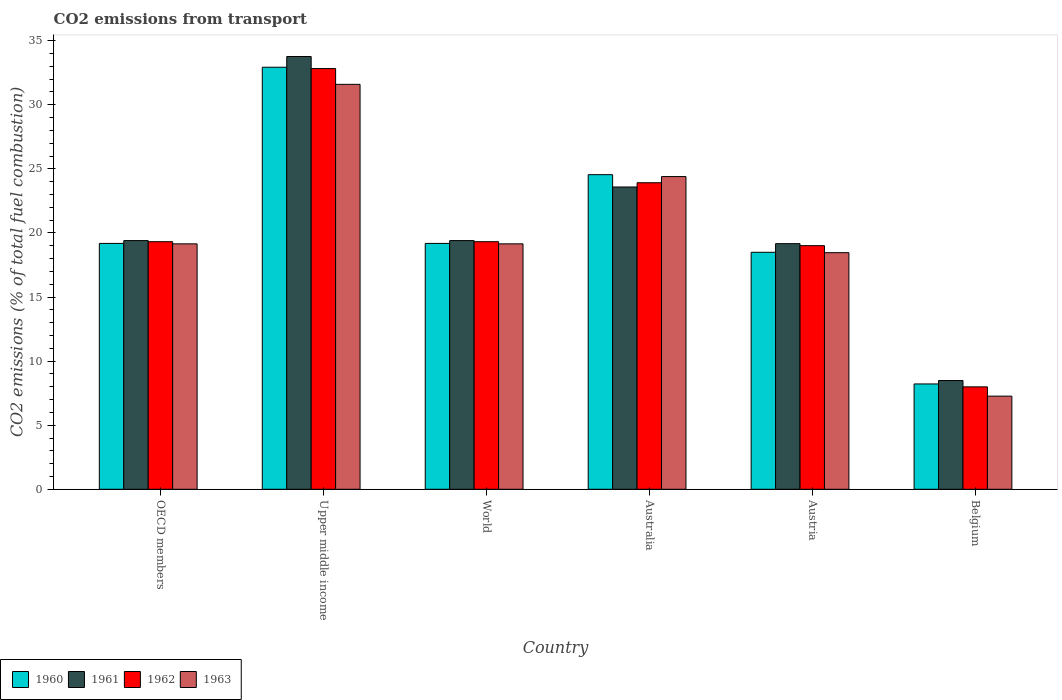Are the number of bars per tick equal to the number of legend labels?
Keep it short and to the point. Yes. What is the label of the 6th group of bars from the left?
Provide a succinct answer. Belgium. What is the total CO2 emitted in 1963 in Belgium?
Offer a terse response. 7.27. Across all countries, what is the maximum total CO2 emitted in 1963?
Provide a succinct answer. 31.59. Across all countries, what is the minimum total CO2 emitted in 1961?
Make the answer very short. 8.49. In which country was the total CO2 emitted in 1963 maximum?
Ensure brevity in your answer.  Upper middle income. What is the total total CO2 emitted in 1963 in the graph?
Provide a succinct answer. 120.01. What is the difference between the total CO2 emitted in 1963 in Belgium and that in World?
Make the answer very short. -11.88. What is the difference between the total CO2 emitted in 1960 in Australia and the total CO2 emitted in 1962 in World?
Provide a succinct answer. 5.23. What is the average total CO2 emitted in 1961 per country?
Provide a short and direct response. 20.63. What is the difference between the total CO2 emitted of/in 1961 and total CO2 emitted of/in 1962 in World?
Give a very brief answer. 0.09. What is the ratio of the total CO2 emitted in 1963 in OECD members to that in Upper middle income?
Offer a terse response. 0.61. Is the total CO2 emitted in 1962 in Australia less than that in OECD members?
Your response must be concise. No. Is the difference between the total CO2 emitted in 1961 in Australia and Upper middle income greater than the difference between the total CO2 emitted in 1962 in Australia and Upper middle income?
Keep it short and to the point. No. What is the difference between the highest and the second highest total CO2 emitted in 1963?
Your response must be concise. 5.25. What is the difference between the highest and the lowest total CO2 emitted in 1960?
Offer a very short reply. 24.71. In how many countries, is the total CO2 emitted in 1963 greater than the average total CO2 emitted in 1963 taken over all countries?
Provide a short and direct response. 2. What does the 3rd bar from the left in Australia represents?
Offer a very short reply. 1962. How many countries are there in the graph?
Provide a succinct answer. 6. What is the difference between two consecutive major ticks on the Y-axis?
Offer a very short reply. 5. Are the values on the major ticks of Y-axis written in scientific E-notation?
Offer a very short reply. No. Does the graph contain grids?
Keep it short and to the point. No. Where does the legend appear in the graph?
Your answer should be very brief. Bottom left. What is the title of the graph?
Offer a very short reply. CO2 emissions from transport. Does "1994" appear as one of the legend labels in the graph?
Ensure brevity in your answer.  No. What is the label or title of the X-axis?
Provide a short and direct response. Country. What is the label or title of the Y-axis?
Give a very brief answer. CO2 emissions (% of total fuel combustion). What is the CO2 emissions (% of total fuel combustion) of 1960 in OECD members?
Make the answer very short. 19.18. What is the CO2 emissions (% of total fuel combustion) in 1961 in OECD members?
Keep it short and to the point. 19.4. What is the CO2 emissions (% of total fuel combustion) of 1962 in OECD members?
Provide a short and direct response. 19.32. What is the CO2 emissions (% of total fuel combustion) of 1963 in OECD members?
Your answer should be compact. 19.15. What is the CO2 emissions (% of total fuel combustion) in 1960 in Upper middle income?
Ensure brevity in your answer.  32.93. What is the CO2 emissions (% of total fuel combustion) in 1961 in Upper middle income?
Provide a succinct answer. 33.76. What is the CO2 emissions (% of total fuel combustion) of 1962 in Upper middle income?
Your response must be concise. 32.82. What is the CO2 emissions (% of total fuel combustion) in 1963 in Upper middle income?
Make the answer very short. 31.59. What is the CO2 emissions (% of total fuel combustion) in 1960 in World?
Provide a short and direct response. 19.18. What is the CO2 emissions (% of total fuel combustion) in 1961 in World?
Provide a succinct answer. 19.4. What is the CO2 emissions (% of total fuel combustion) in 1962 in World?
Your answer should be very brief. 19.32. What is the CO2 emissions (% of total fuel combustion) in 1963 in World?
Offer a terse response. 19.15. What is the CO2 emissions (% of total fuel combustion) in 1960 in Australia?
Give a very brief answer. 24.55. What is the CO2 emissions (% of total fuel combustion) in 1961 in Australia?
Your response must be concise. 23.59. What is the CO2 emissions (% of total fuel combustion) of 1962 in Australia?
Ensure brevity in your answer.  23.92. What is the CO2 emissions (% of total fuel combustion) in 1963 in Australia?
Offer a terse response. 24.4. What is the CO2 emissions (% of total fuel combustion) of 1960 in Austria?
Give a very brief answer. 18.49. What is the CO2 emissions (% of total fuel combustion) of 1961 in Austria?
Keep it short and to the point. 19.16. What is the CO2 emissions (% of total fuel combustion) of 1962 in Austria?
Give a very brief answer. 19.01. What is the CO2 emissions (% of total fuel combustion) of 1963 in Austria?
Ensure brevity in your answer.  18.46. What is the CO2 emissions (% of total fuel combustion) in 1960 in Belgium?
Offer a terse response. 8.22. What is the CO2 emissions (% of total fuel combustion) of 1961 in Belgium?
Ensure brevity in your answer.  8.49. What is the CO2 emissions (% of total fuel combustion) in 1962 in Belgium?
Offer a terse response. 7.99. What is the CO2 emissions (% of total fuel combustion) in 1963 in Belgium?
Offer a terse response. 7.27. Across all countries, what is the maximum CO2 emissions (% of total fuel combustion) of 1960?
Provide a short and direct response. 32.93. Across all countries, what is the maximum CO2 emissions (% of total fuel combustion) of 1961?
Provide a short and direct response. 33.76. Across all countries, what is the maximum CO2 emissions (% of total fuel combustion) in 1962?
Your answer should be very brief. 32.82. Across all countries, what is the maximum CO2 emissions (% of total fuel combustion) in 1963?
Your answer should be very brief. 31.59. Across all countries, what is the minimum CO2 emissions (% of total fuel combustion) of 1960?
Offer a terse response. 8.22. Across all countries, what is the minimum CO2 emissions (% of total fuel combustion) in 1961?
Provide a succinct answer. 8.49. Across all countries, what is the minimum CO2 emissions (% of total fuel combustion) of 1962?
Provide a succinct answer. 7.99. Across all countries, what is the minimum CO2 emissions (% of total fuel combustion) in 1963?
Your answer should be compact. 7.27. What is the total CO2 emissions (% of total fuel combustion) of 1960 in the graph?
Give a very brief answer. 122.55. What is the total CO2 emissions (% of total fuel combustion) of 1961 in the graph?
Make the answer very short. 123.8. What is the total CO2 emissions (% of total fuel combustion) of 1962 in the graph?
Keep it short and to the point. 122.37. What is the total CO2 emissions (% of total fuel combustion) in 1963 in the graph?
Give a very brief answer. 120.01. What is the difference between the CO2 emissions (% of total fuel combustion) in 1960 in OECD members and that in Upper middle income?
Provide a short and direct response. -13.75. What is the difference between the CO2 emissions (% of total fuel combustion) of 1961 in OECD members and that in Upper middle income?
Your answer should be very brief. -14.36. What is the difference between the CO2 emissions (% of total fuel combustion) of 1962 in OECD members and that in Upper middle income?
Your response must be concise. -13.51. What is the difference between the CO2 emissions (% of total fuel combustion) in 1963 in OECD members and that in Upper middle income?
Your response must be concise. -12.44. What is the difference between the CO2 emissions (% of total fuel combustion) of 1961 in OECD members and that in World?
Offer a terse response. 0. What is the difference between the CO2 emissions (% of total fuel combustion) in 1960 in OECD members and that in Australia?
Ensure brevity in your answer.  -5.36. What is the difference between the CO2 emissions (% of total fuel combustion) in 1961 in OECD members and that in Australia?
Provide a short and direct response. -4.18. What is the difference between the CO2 emissions (% of total fuel combustion) in 1962 in OECD members and that in Australia?
Make the answer very short. -4.6. What is the difference between the CO2 emissions (% of total fuel combustion) of 1963 in OECD members and that in Australia?
Give a very brief answer. -5.25. What is the difference between the CO2 emissions (% of total fuel combustion) in 1960 in OECD members and that in Austria?
Ensure brevity in your answer.  0.69. What is the difference between the CO2 emissions (% of total fuel combustion) of 1961 in OECD members and that in Austria?
Give a very brief answer. 0.24. What is the difference between the CO2 emissions (% of total fuel combustion) in 1962 in OECD members and that in Austria?
Your answer should be compact. 0.31. What is the difference between the CO2 emissions (% of total fuel combustion) of 1963 in OECD members and that in Austria?
Offer a terse response. 0.69. What is the difference between the CO2 emissions (% of total fuel combustion) of 1960 in OECD members and that in Belgium?
Give a very brief answer. 10.96. What is the difference between the CO2 emissions (% of total fuel combustion) of 1961 in OECD members and that in Belgium?
Keep it short and to the point. 10.92. What is the difference between the CO2 emissions (% of total fuel combustion) in 1962 in OECD members and that in Belgium?
Offer a very short reply. 11.33. What is the difference between the CO2 emissions (% of total fuel combustion) of 1963 in OECD members and that in Belgium?
Your response must be concise. 11.88. What is the difference between the CO2 emissions (% of total fuel combustion) of 1960 in Upper middle income and that in World?
Your answer should be very brief. 13.75. What is the difference between the CO2 emissions (% of total fuel combustion) in 1961 in Upper middle income and that in World?
Make the answer very short. 14.36. What is the difference between the CO2 emissions (% of total fuel combustion) in 1962 in Upper middle income and that in World?
Offer a terse response. 13.51. What is the difference between the CO2 emissions (% of total fuel combustion) of 1963 in Upper middle income and that in World?
Ensure brevity in your answer.  12.44. What is the difference between the CO2 emissions (% of total fuel combustion) in 1960 in Upper middle income and that in Australia?
Your answer should be compact. 8.38. What is the difference between the CO2 emissions (% of total fuel combustion) in 1961 in Upper middle income and that in Australia?
Make the answer very short. 10.18. What is the difference between the CO2 emissions (% of total fuel combustion) in 1962 in Upper middle income and that in Australia?
Make the answer very short. 8.91. What is the difference between the CO2 emissions (% of total fuel combustion) of 1963 in Upper middle income and that in Australia?
Give a very brief answer. 7.2. What is the difference between the CO2 emissions (% of total fuel combustion) of 1960 in Upper middle income and that in Austria?
Ensure brevity in your answer.  14.44. What is the difference between the CO2 emissions (% of total fuel combustion) of 1961 in Upper middle income and that in Austria?
Keep it short and to the point. 14.6. What is the difference between the CO2 emissions (% of total fuel combustion) of 1962 in Upper middle income and that in Austria?
Keep it short and to the point. 13.82. What is the difference between the CO2 emissions (% of total fuel combustion) in 1963 in Upper middle income and that in Austria?
Provide a short and direct response. 13.13. What is the difference between the CO2 emissions (% of total fuel combustion) of 1960 in Upper middle income and that in Belgium?
Make the answer very short. 24.71. What is the difference between the CO2 emissions (% of total fuel combustion) in 1961 in Upper middle income and that in Belgium?
Make the answer very short. 25.28. What is the difference between the CO2 emissions (% of total fuel combustion) of 1962 in Upper middle income and that in Belgium?
Your response must be concise. 24.83. What is the difference between the CO2 emissions (% of total fuel combustion) of 1963 in Upper middle income and that in Belgium?
Your answer should be compact. 24.33. What is the difference between the CO2 emissions (% of total fuel combustion) in 1960 in World and that in Australia?
Offer a terse response. -5.36. What is the difference between the CO2 emissions (% of total fuel combustion) in 1961 in World and that in Australia?
Your response must be concise. -4.18. What is the difference between the CO2 emissions (% of total fuel combustion) in 1962 in World and that in Australia?
Keep it short and to the point. -4.6. What is the difference between the CO2 emissions (% of total fuel combustion) in 1963 in World and that in Australia?
Offer a very short reply. -5.25. What is the difference between the CO2 emissions (% of total fuel combustion) in 1960 in World and that in Austria?
Ensure brevity in your answer.  0.69. What is the difference between the CO2 emissions (% of total fuel combustion) of 1961 in World and that in Austria?
Offer a terse response. 0.24. What is the difference between the CO2 emissions (% of total fuel combustion) of 1962 in World and that in Austria?
Offer a very short reply. 0.31. What is the difference between the CO2 emissions (% of total fuel combustion) of 1963 in World and that in Austria?
Your response must be concise. 0.69. What is the difference between the CO2 emissions (% of total fuel combustion) in 1960 in World and that in Belgium?
Keep it short and to the point. 10.96. What is the difference between the CO2 emissions (% of total fuel combustion) of 1961 in World and that in Belgium?
Offer a terse response. 10.92. What is the difference between the CO2 emissions (% of total fuel combustion) in 1962 in World and that in Belgium?
Your answer should be very brief. 11.33. What is the difference between the CO2 emissions (% of total fuel combustion) of 1963 in World and that in Belgium?
Your answer should be very brief. 11.88. What is the difference between the CO2 emissions (% of total fuel combustion) in 1960 in Australia and that in Austria?
Your response must be concise. 6.06. What is the difference between the CO2 emissions (% of total fuel combustion) in 1961 in Australia and that in Austria?
Make the answer very short. 4.42. What is the difference between the CO2 emissions (% of total fuel combustion) of 1962 in Australia and that in Austria?
Your answer should be compact. 4.91. What is the difference between the CO2 emissions (% of total fuel combustion) of 1963 in Australia and that in Austria?
Give a very brief answer. 5.94. What is the difference between the CO2 emissions (% of total fuel combustion) in 1960 in Australia and that in Belgium?
Your answer should be compact. 16.33. What is the difference between the CO2 emissions (% of total fuel combustion) in 1961 in Australia and that in Belgium?
Provide a succinct answer. 15.1. What is the difference between the CO2 emissions (% of total fuel combustion) of 1962 in Australia and that in Belgium?
Offer a very short reply. 15.93. What is the difference between the CO2 emissions (% of total fuel combustion) of 1963 in Australia and that in Belgium?
Give a very brief answer. 17.13. What is the difference between the CO2 emissions (% of total fuel combustion) in 1960 in Austria and that in Belgium?
Make the answer very short. 10.27. What is the difference between the CO2 emissions (% of total fuel combustion) of 1961 in Austria and that in Belgium?
Give a very brief answer. 10.68. What is the difference between the CO2 emissions (% of total fuel combustion) in 1962 in Austria and that in Belgium?
Make the answer very short. 11.02. What is the difference between the CO2 emissions (% of total fuel combustion) in 1963 in Austria and that in Belgium?
Give a very brief answer. 11.19. What is the difference between the CO2 emissions (% of total fuel combustion) in 1960 in OECD members and the CO2 emissions (% of total fuel combustion) in 1961 in Upper middle income?
Your response must be concise. -14.58. What is the difference between the CO2 emissions (% of total fuel combustion) of 1960 in OECD members and the CO2 emissions (% of total fuel combustion) of 1962 in Upper middle income?
Give a very brief answer. -13.64. What is the difference between the CO2 emissions (% of total fuel combustion) in 1960 in OECD members and the CO2 emissions (% of total fuel combustion) in 1963 in Upper middle income?
Make the answer very short. -12.41. What is the difference between the CO2 emissions (% of total fuel combustion) of 1961 in OECD members and the CO2 emissions (% of total fuel combustion) of 1962 in Upper middle income?
Your answer should be compact. -13.42. What is the difference between the CO2 emissions (% of total fuel combustion) in 1961 in OECD members and the CO2 emissions (% of total fuel combustion) in 1963 in Upper middle income?
Keep it short and to the point. -12.19. What is the difference between the CO2 emissions (% of total fuel combustion) in 1962 in OECD members and the CO2 emissions (% of total fuel combustion) in 1963 in Upper middle income?
Make the answer very short. -12.28. What is the difference between the CO2 emissions (% of total fuel combustion) in 1960 in OECD members and the CO2 emissions (% of total fuel combustion) in 1961 in World?
Ensure brevity in your answer.  -0.22. What is the difference between the CO2 emissions (% of total fuel combustion) of 1960 in OECD members and the CO2 emissions (% of total fuel combustion) of 1962 in World?
Provide a short and direct response. -0.13. What is the difference between the CO2 emissions (% of total fuel combustion) in 1960 in OECD members and the CO2 emissions (% of total fuel combustion) in 1963 in World?
Offer a very short reply. 0.03. What is the difference between the CO2 emissions (% of total fuel combustion) of 1961 in OECD members and the CO2 emissions (% of total fuel combustion) of 1962 in World?
Your answer should be very brief. 0.09. What is the difference between the CO2 emissions (% of total fuel combustion) in 1961 in OECD members and the CO2 emissions (% of total fuel combustion) in 1963 in World?
Provide a succinct answer. 0.25. What is the difference between the CO2 emissions (% of total fuel combustion) of 1962 in OECD members and the CO2 emissions (% of total fuel combustion) of 1963 in World?
Offer a terse response. 0.17. What is the difference between the CO2 emissions (% of total fuel combustion) of 1960 in OECD members and the CO2 emissions (% of total fuel combustion) of 1961 in Australia?
Your answer should be very brief. -4.4. What is the difference between the CO2 emissions (% of total fuel combustion) of 1960 in OECD members and the CO2 emissions (% of total fuel combustion) of 1962 in Australia?
Offer a very short reply. -4.73. What is the difference between the CO2 emissions (% of total fuel combustion) in 1960 in OECD members and the CO2 emissions (% of total fuel combustion) in 1963 in Australia?
Ensure brevity in your answer.  -5.21. What is the difference between the CO2 emissions (% of total fuel combustion) of 1961 in OECD members and the CO2 emissions (% of total fuel combustion) of 1962 in Australia?
Make the answer very short. -4.51. What is the difference between the CO2 emissions (% of total fuel combustion) of 1961 in OECD members and the CO2 emissions (% of total fuel combustion) of 1963 in Australia?
Your response must be concise. -4.99. What is the difference between the CO2 emissions (% of total fuel combustion) of 1962 in OECD members and the CO2 emissions (% of total fuel combustion) of 1963 in Australia?
Ensure brevity in your answer.  -5.08. What is the difference between the CO2 emissions (% of total fuel combustion) of 1960 in OECD members and the CO2 emissions (% of total fuel combustion) of 1961 in Austria?
Offer a terse response. 0.02. What is the difference between the CO2 emissions (% of total fuel combustion) of 1960 in OECD members and the CO2 emissions (% of total fuel combustion) of 1962 in Austria?
Provide a short and direct response. 0.18. What is the difference between the CO2 emissions (% of total fuel combustion) of 1960 in OECD members and the CO2 emissions (% of total fuel combustion) of 1963 in Austria?
Ensure brevity in your answer.  0.72. What is the difference between the CO2 emissions (% of total fuel combustion) in 1961 in OECD members and the CO2 emissions (% of total fuel combustion) in 1962 in Austria?
Give a very brief answer. 0.4. What is the difference between the CO2 emissions (% of total fuel combustion) of 1961 in OECD members and the CO2 emissions (% of total fuel combustion) of 1963 in Austria?
Give a very brief answer. 0.94. What is the difference between the CO2 emissions (% of total fuel combustion) in 1962 in OECD members and the CO2 emissions (% of total fuel combustion) in 1963 in Austria?
Give a very brief answer. 0.86. What is the difference between the CO2 emissions (% of total fuel combustion) in 1960 in OECD members and the CO2 emissions (% of total fuel combustion) in 1961 in Belgium?
Your answer should be very brief. 10.7. What is the difference between the CO2 emissions (% of total fuel combustion) of 1960 in OECD members and the CO2 emissions (% of total fuel combustion) of 1962 in Belgium?
Your answer should be compact. 11.19. What is the difference between the CO2 emissions (% of total fuel combustion) of 1960 in OECD members and the CO2 emissions (% of total fuel combustion) of 1963 in Belgium?
Your response must be concise. 11.92. What is the difference between the CO2 emissions (% of total fuel combustion) of 1961 in OECD members and the CO2 emissions (% of total fuel combustion) of 1962 in Belgium?
Ensure brevity in your answer.  11.41. What is the difference between the CO2 emissions (% of total fuel combustion) in 1961 in OECD members and the CO2 emissions (% of total fuel combustion) in 1963 in Belgium?
Offer a very short reply. 12.14. What is the difference between the CO2 emissions (% of total fuel combustion) of 1962 in OECD members and the CO2 emissions (% of total fuel combustion) of 1963 in Belgium?
Make the answer very short. 12.05. What is the difference between the CO2 emissions (% of total fuel combustion) of 1960 in Upper middle income and the CO2 emissions (% of total fuel combustion) of 1961 in World?
Keep it short and to the point. 13.53. What is the difference between the CO2 emissions (% of total fuel combustion) of 1960 in Upper middle income and the CO2 emissions (% of total fuel combustion) of 1962 in World?
Offer a terse response. 13.61. What is the difference between the CO2 emissions (% of total fuel combustion) of 1960 in Upper middle income and the CO2 emissions (% of total fuel combustion) of 1963 in World?
Provide a succinct answer. 13.78. What is the difference between the CO2 emissions (% of total fuel combustion) in 1961 in Upper middle income and the CO2 emissions (% of total fuel combustion) in 1962 in World?
Give a very brief answer. 14.45. What is the difference between the CO2 emissions (% of total fuel combustion) of 1961 in Upper middle income and the CO2 emissions (% of total fuel combustion) of 1963 in World?
Give a very brief answer. 14.62. What is the difference between the CO2 emissions (% of total fuel combustion) of 1962 in Upper middle income and the CO2 emissions (% of total fuel combustion) of 1963 in World?
Make the answer very short. 13.68. What is the difference between the CO2 emissions (% of total fuel combustion) of 1960 in Upper middle income and the CO2 emissions (% of total fuel combustion) of 1961 in Australia?
Keep it short and to the point. 9.34. What is the difference between the CO2 emissions (% of total fuel combustion) of 1960 in Upper middle income and the CO2 emissions (% of total fuel combustion) of 1962 in Australia?
Offer a very short reply. 9.01. What is the difference between the CO2 emissions (% of total fuel combustion) of 1960 in Upper middle income and the CO2 emissions (% of total fuel combustion) of 1963 in Australia?
Your answer should be very brief. 8.53. What is the difference between the CO2 emissions (% of total fuel combustion) of 1961 in Upper middle income and the CO2 emissions (% of total fuel combustion) of 1962 in Australia?
Ensure brevity in your answer.  9.85. What is the difference between the CO2 emissions (% of total fuel combustion) in 1961 in Upper middle income and the CO2 emissions (% of total fuel combustion) in 1963 in Australia?
Offer a terse response. 9.37. What is the difference between the CO2 emissions (% of total fuel combustion) of 1962 in Upper middle income and the CO2 emissions (% of total fuel combustion) of 1963 in Australia?
Your answer should be very brief. 8.43. What is the difference between the CO2 emissions (% of total fuel combustion) of 1960 in Upper middle income and the CO2 emissions (% of total fuel combustion) of 1961 in Austria?
Your answer should be very brief. 13.77. What is the difference between the CO2 emissions (% of total fuel combustion) of 1960 in Upper middle income and the CO2 emissions (% of total fuel combustion) of 1962 in Austria?
Provide a succinct answer. 13.92. What is the difference between the CO2 emissions (% of total fuel combustion) of 1960 in Upper middle income and the CO2 emissions (% of total fuel combustion) of 1963 in Austria?
Ensure brevity in your answer.  14.47. What is the difference between the CO2 emissions (% of total fuel combustion) in 1961 in Upper middle income and the CO2 emissions (% of total fuel combustion) in 1962 in Austria?
Provide a short and direct response. 14.76. What is the difference between the CO2 emissions (% of total fuel combustion) in 1961 in Upper middle income and the CO2 emissions (% of total fuel combustion) in 1963 in Austria?
Provide a short and direct response. 15.3. What is the difference between the CO2 emissions (% of total fuel combustion) of 1962 in Upper middle income and the CO2 emissions (% of total fuel combustion) of 1963 in Austria?
Offer a very short reply. 14.36. What is the difference between the CO2 emissions (% of total fuel combustion) of 1960 in Upper middle income and the CO2 emissions (% of total fuel combustion) of 1961 in Belgium?
Provide a succinct answer. 24.44. What is the difference between the CO2 emissions (% of total fuel combustion) in 1960 in Upper middle income and the CO2 emissions (% of total fuel combustion) in 1962 in Belgium?
Make the answer very short. 24.94. What is the difference between the CO2 emissions (% of total fuel combustion) of 1960 in Upper middle income and the CO2 emissions (% of total fuel combustion) of 1963 in Belgium?
Offer a terse response. 25.66. What is the difference between the CO2 emissions (% of total fuel combustion) in 1961 in Upper middle income and the CO2 emissions (% of total fuel combustion) in 1962 in Belgium?
Keep it short and to the point. 25.77. What is the difference between the CO2 emissions (% of total fuel combustion) in 1961 in Upper middle income and the CO2 emissions (% of total fuel combustion) in 1963 in Belgium?
Keep it short and to the point. 26.5. What is the difference between the CO2 emissions (% of total fuel combustion) of 1962 in Upper middle income and the CO2 emissions (% of total fuel combustion) of 1963 in Belgium?
Ensure brevity in your answer.  25.56. What is the difference between the CO2 emissions (% of total fuel combustion) of 1960 in World and the CO2 emissions (% of total fuel combustion) of 1961 in Australia?
Keep it short and to the point. -4.4. What is the difference between the CO2 emissions (% of total fuel combustion) in 1960 in World and the CO2 emissions (% of total fuel combustion) in 1962 in Australia?
Keep it short and to the point. -4.73. What is the difference between the CO2 emissions (% of total fuel combustion) in 1960 in World and the CO2 emissions (% of total fuel combustion) in 1963 in Australia?
Give a very brief answer. -5.21. What is the difference between the CO2 emissions (% of total fuel combustion) of 1961 in World and the CO2 emissions (% of total fuel combustion) of 1962 in Australia?
Provide a succinct answer. -4.51. What is the difference between the CO2 emissions (% of total fuel combustion) of 1961 in World and the CO2 emissions (% of total fuel combustion) of 1963 in Australia?
Your answer should be compact. -4.99. What is the difference between the CO2 emissions (% of total fuel combustion) of 1962 in World and the CO2 emissions (% of total fuel combustion) of 1963 in Australia?
Provide a succinct answer. -5.08. What is the difference between the CO2 emissions (% of total fuel combustion) of 1960 in World and the CO2 emissions (% of total fuel combustion) of 1961 in Austria?
Offer a terse response. 0.02. What is the difference between the CO2 emissions (% of total fuel combustion) in 1960 in World and the CO2 emissions (% of total fuel combustion) in 1962 in Austria?
Make the answer very short. 0.18. What is the difference between the CO2 emissions (% of total fuel combustion) of 1960 in World and the CO2 emissions (% of total fuel combustion) of 1963 in Austria?
Provide a short and direct response. 0.72. What is the difference between the CO2 emissions (% of total fuel combustion) of 1961 in World and the CO2 emissions (% of total fuel combustion) of 1962 in Austria?
Your answer should be very brief. 0.4. What is the difference between the CO2 emissions (% of total fuel combustion) of 1961 in World and the CO2 emissions (% of total fuel combustion) of 1963 in Austria?
Your response must be concise. 0.94. What is the difference between the CO2 emissions (% of total fuel combustion) in 1962 in World and the CO2 emissions (% of total fuel combustion) in 1963 in Austria?
Ensure brevity in your answer.  0.86. What is the difference between the CO2 emissions (% of total fuel combustion) in 1960 in World and the CO2 emissions (% of total fuel combustion) in 1961 in Belgium?
Keep it short and to the point. 10.7. What is the difference between the CO2 emissions (% of total fuel combustion) of 1960 in World and the CO2 emissions (% of total fuel combustion) of 1962 in Belgium?
Provide a short and direct response. 11.19. What is the difference between the CO2 emissions (% of total fuel combustion) of 1960 in World and the CO2 emissions (% of total fuel combustion) of 1963 in Belgium?
Offer a terse response. 11.92. What is the difference between the CO2 emissions (% of total fuel combustion) of 1961 in World and the CO2 emissions (% of total fuel combustion) of 1962 in Belgium?
Your answer should be compact. 11.41. What is the difference between the CO2 emissions (% of total fuel combustion) in 1961 in World and the CO2 emissions (% of total fuel combustion) in 1963 in Belgium?
Provide a short and direct response. 12.14. What is the difference between the CO2 emissions (% of total fuel combustion) of 1962 in World and the CO2 emissions (% of total fuel combustion) of 1963 in Belgium?
Give a very brief answer. 12.05. What is the difference between the CO2 emissions (% of total fuel combustion) in 1960 in Australia and the CO2 emissions (% of total fuel combustion) in 1961 in Austria?
Your answer should be very brief. 5.38. What is the difference between the CO2 emissions (% of total fuel combustion) in 1960 in Australia and the CO2 emissions (% of total fuel combustion) in 1962 in Austria?
Your answer should be very brief. 5.54. What is the difference between the CO2 emissions (% of total fuel combustion) in 1960 in Australia and the CO2 emissions (% of total fuel combustion) in 1963 in Austria?
Provide a short and direct response. 6.09. What is the difference between the CO2 emissions (% of total fuel combustion) of 1961 in Australia and the CO2 emissions (% of total fuel combustion) of 1962 in Austria?
Offer a very short reply. 4.58. What is the difference between the CO2 emissions (% of total fuel combustion) of 1961 in Australia and the CO2 emissions (% of total fuel combustion) of 1963 in Austria?
Your answer should be very brief. 5.13. What is the difference between the CO2 emissions (% of total fuel combustion) of 1962 in Australia and the CO2 emissions (% of total fuel combustion) of 1963 in Austria?
Keep it short and to the point. 5.46. What is the difference between the CO2 emissions (% of total fuel combustion) in 1960 in Australia and the CO2 emissions (% of total fuel combustion) in 1961 in Belgium?
Offer a terse response. 16.06. What is the difference between the CO2 emissions (% of total fuel combustion) of 1960 in Australia and the CO2 emissions (% of total fuel combustion) of 1962 in Belgium?
Keep it short and to the point. 16.56. What is the difference between the CO2 emissions (% of total fuel combustion) of 1960 in Australia and the CO2 emissions (% of total fuel combustion) of 1963 in Belgium?
Your answer should be very brief. 17.28. What is the difference between the CO2 emissions (% of total fuel combustion) in 1961 in Australia and the CO2 emissions (% of total fuel combustion) in 1962 in Belgium?
Offer a very short reply. 15.59. What is the difference between the CO2 emissions (% of total fuel combustion) in 1961 in Australia and the CO2 emissions (% of total fuel combustion) in 1963 in Belgium?
Your answer should be very brief. 16.32. What is the difference between the CO2 emissions (% of total fuel combustion) in 1962 in Australia and the CO2 emissions (% of total fuel combustion) in 1963 in Belgium?
Provide a short and direct response. 16.65. What is the difference between the CO2 emissions (% of total fuel combustion) in 1960 in Austria and the CO2 emissions (% of total fuel combustion) in 1961 in Belgium?
Make the answer very short. 10. What is the difference between the CO2 emissions (% of total fuel combustion) of 1960 in Austria and the CO2 emissions (% of total fuel combustion) of 1962 in Belgium?
Offer a very short reply. 10.5. What is the difference between the CO2 emissions (% of total fuel combustion) in 1960 in Austria and the CO2 emissions (% of total fuel combustion) in 1963 in Belgium?
Provide a short and direct response. 11.22. What is the difference between the CO2 emissions (% of total fuel combustion) of 1961 in Austria and the CO2 emissions (% of total fuel combustion) of 1962 in Belgium?
Make the answer very short. 11.17. What is the difference between the CO2 emissions (% of total fuel combustion) in 1961 in Austria and the CO2 emissions (% of total fuel combustion) in 1963 in Belgium?
Make the answer very short. 11.9. What is the difference between the CO2 emissions (% of total fuel combustion) of 1962 in Austria and the CO2 emissions (% of total fuel combustion) of 1963 in Belgium?
Your response must be concise. 11.74. What is the average CO2 emissions (% of total fuel combustion) in 1960 per country?
Provide a succinct answer. 20.42. What is the average CO2 emissions (% of total fuel combustion) in 1961 per country?
Provide a short and direct response. 20.63. What is the average CO2 emissions (% of total fuel combustion) in 1962 per country?
Keep it short and to the point. 20.4. What is the average CO2 emissions (% of total fuel combustion) in 1963 per country?
Your response must be concise. 20. What is the difference between the CO2 emissions (% of total fuel combustion) in 1960 and CO2 emissions (% of total fuel combustion) in 1961 in OECD members?
Provide a succinct answer. -0.22. What is the difference between the CO2 emissions (% of total fuel combustion) in 1960 and CO2 emissions (% of total fuel combustion) in 1962 in OECD members?
Provide a succinct answer. -0.13. What is the difference between the CO2 emissions (% of total fuel combustion) in 1960 and CO2 emissions (% of total fuel combustion) in 1963 in OECD members?
Provide a succinct answer. 0.03. What is the difference between the CO2 emissions (% of total fuel combustion) in 1961 and CO2 emissions (% of total fuel combustion) in 1962 in OECD members?
Your answer should be very brief. 0.09. What is the difference between the CO2 emissions (% of total fuel combustion) of 1961 and CO2 emissions (% of total fuel combustion) of 1963 in OECD members?
Offer a very short reply. 0.25. What is the difference between the CO2 emissions (% of total fuel combustion) in 1962 and CO2 emissions (% of total fuel combustion) in 1963 in OECD members?
Offer a very short reply. 0.17. What is the difference between the CO2 emissions (% of total fuel combustion) of 1960 and CO2 emissions (% of total fuel combustion) of 1961 in Upper middle income?
Offer a very short reply. -0.84. What is the difference between the CO2 emissions (% of total fuel combustion) of 1960 and CO2 emissions (% of total fuel combustion) of 1962 in Upper middle income?
Ensure brevity in your answer.  0.1. What is the difference between the CO2 emissions (% of total fuel combustion) of 1960 and CO2 emissions (% of total fuel combustion) of 1963 in Upper middle income?
Provide a succinct answer. 1.34. What is the difference between the CO2 emissions (% of total fuel combustion) of 1961 and CO2 emissions (% of total fuel combustion) of 1962 in Upper middle income?
Ensure brevity in your answer.  0.94. What is the difference between the CO2 emissions (% of total fuel combustion) in 1961 and CO2 emissions (% of total fuel combustion) in 1963 in Upper middle income?
Offer a very short reply. 2.17. What is the difference between the CO2 emissions (% of total fuel combustion) in 1962 and CO2 emissions (% of total fuel combustion) in 1963 in Upper middle income?
Give a very brief answer. 1.23. What is the difference between the CO2 emissions (% of total fuel combustion) in 1960 and CO2 emissions (% of total fuel combustion) in 1961 in World?
Your answer should be compact. -0.22. What is the difference between the CO2 emissions (% of total fuel combustion) of 1960 and CO2 emissions (% of total fuel combustion) of 1962 in World?
Provide a succinct answer. -0.13. What is the difference between the CO2 emissions (% of total fuel combustion) in 1960 and CO2 emissions (% of total fuel combustion) in 1963 in World?
Ensure brevity in your answer.  0.03. What is the difference between the CO2 emissions (% of total fuel combustion) of 1961 and CO2 emissions (% of total fuel combustion) of 1962 in World?
Make the answer very short. 0.09. What is the difference between the CO2 emissions (% of total fuel combustion) of 1961 and CO2 emissions (% of total fuel combustion) of 1963 in World?
Your answer should be very brief. 0.25. What is the difference between the CO2 emissions (% of total fuel combustion) in 1962 and CO2 emissions (% of total fuel combustion) in 1963 in World?
Offer a terse response. 0.17. What is the difference between the CO2 emissions (% of total fuel combustion) of 1960 and CO2 emissions (% of total fuel combustion) of 1961 in Australia?
Your response must be concise. 0.96. What is the difference between the CO2 emissions (% of total fuel combustion) of 1960 and CO2 emissions (% of total fuel combustion) of 1962 in Australia?
Your response must be concise. 0.63. What is the difference between the CO2 emissions (% of total fuel combustion) of 1960 and CO2 emissions (% of total fuel combustion) of 1963 in Australia?
Your answer should be very brief. 0.15. What is the difference between the CO2 emissions (% of total fuel combustion) of 1961 and CO2 emissions (% of total fuel combustion) of 1962 in Australia?
Your answer should be compact. -0.33. What is the difference between the CO2 emissions (% of total fuel combustion) in 1961 and CO2 emissions (% of total fuel combustion) in 1963 in Australia?
Provide a short and direct response. -0.81. What is the difference between the CO2 emissions (% of total fuel combustion) of 1962 and CO2 emissions (% of total fuel combustion) of 1963 in Australia?
Make the answer very short. -0.48. What is the difference between the CO2 emissions (% of total fuel combustion) of 1960 and CO2 emissions (% of total fuel combustion) of 1961 in Austria?
Offer a very short reply. -0.67. What is the difference between the CO2 emissions (% of total fuel combustion) in 1960 and CO2 emissions (% of total fuel combustion) in 1962 in Austria?
Keep it short and to the point. -0.52. What is the difference between the CO2 emissions (% of total fuel combustion) of 1960 and CO2 emissions (% of total fuel combustion) of 1963 in Austria?
Offer a very short reply. 0.03. What is the difference between the CO2 emissions (% of total fuel combustion) of 1961 and CO2 emissions (% of total fuel combustion) of 1962 in Austria?
Your answer should be very brief. 0.15. What is the difference between the CO2 emissions (% of total fuel combustion) in 1961 and CO2 emissions (% of total fuel combustion) in 1963 in Austria?
Your answer should be very brief. 0.7. What is the difference between the CO2 emissions (% of total fuel combustion) of 1962 and CO2 emissions (% of total fuel combustion) of 1963 in Austria?
Offer a very short reply. 0.55. What is the difference between the CO2 emissions (% of total fuel combustion) of 1960 and CO2 emissions (% of total fuel combustion) of 1961 in Belgium?
Your answer should be very brief. -0.27. What is the difference between the CO2 emissions (% of total fuel combustion) in 1960 and CO2 emissions (% of total fuel combustion) in 1962 in Belgium?
Provide a succinct answer. 0.23. What is the difference between the CO2 emissions (% of total fuel combustion) in 1960 and CO2 emissions (% of total fuel combustion) in 1963 in Belgium?
Provide a succinct answer. 0.95. What is the difference between the CO2 emissions (% of total fuel combustion) in 1961 and CO2 emissions (% of total fuel combustion) in 1962 in Belgium?
Make the answer very short. 0.49. What is the difference between the CO2 emissions (% of total fuel combustion) of 1961 and CO2 emissions (% of total fuel combustion) of 1963 in Belgium?
Your response must be concise. 1.22. What is the difference between the CO2 emissions (% of total fuel combustion) in 1962 and CO2 emissions (% of total fuel combustion) in 1963 in Belgium?
Offer a terse response. 0.72. What is the ratio of the CO2 emissions (% of total fuel combustion) of 1960 in OECD members to that in Upper middle income?
Give a very brief answer. 0.58. What is the ratio of the CO2 emissions (% of total fuel combustion) in 1961 in OECD members to that in Upper middle income?
Offer a very short reply. 0.57. What is the ratio of the CO2 emissions (% of total fuel combustion) in 1962 in OECD members to that in Upper middle income?
Your answer should be very brief. 0.59. What is the ratio of the CO2 emissions (% of total fuel combustion) of 1963 in OECD members to that in Upper middle income?
Your answer should be very brief. 0.61. What is the ratio of the CO2 emissions (% of total fuel combustion) of 1963 in OECD members to that in World?
Provide a succinct answer. 1. What is the ratio of the CO2 emissions (% of total fuel combustion) in 1960 in OECD members to that in Australia?
Make the answer very short. 0.78. What is the ratio of the CO2 emissions (% of total fuel combustion) of 1961 in OECD members to that in Australia?
Offer a very short reply. 0.82. What is the ratio of the CO2 emissions (% of total fuel combustion) in 1962 in OECD members to that in Australia?
Provide a succinct answer. 0.81. What is the ratio of the CO2 emissions (% of total fuel combustion) in 1963 in OECD members to that in Australia?
Offer a very short reply. 0.78. What is the ratio of the CO2 emissions (% of total fuel combustion) in 1960 in OECD members to that in Austria?
Offer a very short reply. 1.04. What is the ratio of the CO2 emissions (% of total fuel combustion) of 1961 in OECD members to that in Austria?
Your answer should be compact. 1.01. What is the ratio of the CO2 emissions (% of total fuel combustion) in 1962 in OECD members to that in Austria?
Give a very brief answer. 1.02. What is the ratio of the CO2 emissions (% of total fuel combustion) of 1963 in OECD members to that in Austria?
Give a very brief answer. 1.04. What is the ratio of the CO2 emissions (% of total fuel combustion) in 1960 in OECD members to that in Belgium?
Provide a succinct answer. 2.33. What is the ratio of the CO2 emissions (% of total fuel combustion) of 1961 in OECD members to that in Belgium?
Make the answer very short. 2.29. What is the ratio of the CO2 emissions (% of total fuel combustion) in 1962 in OECD members to that in Belgium?
Your response must be concise. 2.42. What is the ratio of the CO2 emissions (% of total fuel combustion) in 1963 in OECD members to that in Belgium?
Your answer should be very brief. 2.64. What is the ratio of the CO2 emissions (% of total fuel combustion) of 1960 in Upper middle income to that in World?
Provide a succinct answer. 1.72. What is the ratio of the CO2 emissions (% of total fuel combustion) of 1961 in Upper middle income to that in World?
Your answer should be very brief. 1.74. What is the ratio of the CO2 emissions (% of total fuel combustion) in 1962 in Upper middle income to that in World?
Offer a terse response. 1.7. What is the ratio of the CO2 emissions (% of total fuel combustion) of 1963 in Upper middle income to that in World?
Your response must be concise. 1.65. What is the ratio of the CO2 emissions (% of total fuel combustion) in 1960 in Upper middle income to that in Australia?
Keep it short and to the point. 1.34. What is the ratio of the CO2 emissions (% of total fuel combustion) of 1961 in Upper middle income to that in Australia?
Provide a succinct answer. 1.43. What is the ratio of the CO2 emissions (% of total fuel combustion) of 1962 in Upper middle income to that in Australia?
Your response must be concise. 1.37. What is the ratio of the CO2 emissions (% of total fuel combustion) of 1963 in Upper middle income to that in Australia?
Offer a terse response. 1.29. What is the ratio of the CO2 emissions (% of total fuel combustion) in 1960 in Upper middle income to that in Austria?
Offer a very short reply. 1.78. What is the ratio of the CO2 emissions (% of total fuel combustion) in 1961 in Upper middle income to that in Austria?
Your answer should be compact. 1.76. What is the ratio of the CO2 emissions (% of total fuel combustion) of 1962 in Upper middle income to that in Austria?
Provide a short and direct response. 1.73. What is the ratio of the CO2 emissions (% of total fuel combustion) of 1963 in Upper middle income to that in Austria?
Keep it short and to the point. 1.71. What is the ratio of the CO2 emissions (% of total fuel combustion) in 1960 in Upper middle income to that in Belgium?
Your answer should be very brief. 4.01. What is the ratio of the CO2 emissions (% of total fuel combustion) of 1961 in Upper middle income to that in Belgium?
Your response must be concise. 3.98. What is the ratio of the CO2 emissions (% of total fuel combustion) in 1962 in Upper middle income to that in Belgium?
Your answer should be very brief. 4.11. What is the ratio of the CO2 emissions (% of total fuel combustion) in 1963 in Upper middle income to that in Belgium?
Give a very brief answer. 4.35. What is the ratio of the CO2 emissions (% of total fuel combustion) in 1960 in World to that in Australia?
Your response must be concise. 0.78. What is the ratio of the CO2 emissions (% of total fuel combustion) of 1961 in World to that in Australia?
Give a very brief answer. 0.82. What is the ratio of the CO2 emissions (% of total fuel combustion) in 1962 in World to that in Australia?
Offer a very short reply. 0.81. What is the ratio of the CO2 emissions (% of total fuel combustion) in 1963 in World to that in Australia?
Your response must be concise. 0.78. What is the ratio of the CO2 emissions (% of total fuel combustion) of 1960 in World to that in Austria?
Offer a terse response. 1.04. What is the ratio of the CO2 emissions (% of total fuel combustion) of 1961 in World to that in Austria?
Your response must be concise. 1.01. What is the ratio of the CO2 emissions (% of total fuel combustion) in 1962 in World to that in Austria?
Provide a short and direct response. 1.02. What is the ratio of the CO2 emissions (% of total fuel combustion) of 1963 in World to that in Austria?
Ensure brevity in your answer.  1.04. What is the ratio of the CO2 emissions (% of total fuel combustion) in 1960 in World to that in Belgium?
Provide a short and direct response. 2.33. What is the ratio of the CO2 emissions (% of total fuel combustion) in 1961 in World to that in Belgium?
Keep it short and to the point. 2.29. What is the ratio of the CO2 emissions (% of total fuel combustion) of 1962 in World to that in Belgium?
Make the answer very short. 2.42. What is the ratio of the CO2 emissions (% of total fuel combustion) of 1963 in World to that in Belgium?
Your answer should be compact. 2.64. What is the ratio of the CO2 emissions (% of total fuel combustion) in 1960 in Australia to that in Austria?
Keep it short and to the point. 1.33. What is the ratio of the CO2 emissions (% of total fuel combustion) in 1961 in Australia to that in Austria?
Make the answer very short. 1.23. What is the ratio of the CO2 emissions (% of total fuel combustion) in 1962 in Australia to that in Austria?
Keep it short and to the point. 1.26. What is the ratio of the CO2 emissions (% of total fuel combustion) in 1963 in Australia to that in Austria?
Your answer should be compact. 1.32. What is the ratio of the CO2 emissions (% of total fuel combustion) of 1960 in Australia to that in Belgium?
Keep it short and to the point. 2.99. What is the ratio of the CO2 emissions (% of total fuel combustion) of 1961 in Australia to that in Belgium?
Your answer should be very brief. 2.78. What is the ratio of the CO2 emissions (% of total fuel combustion) of 1962 in Australia to that in Belgium?
Your response must be concise. 2.99. What is the ratio of the CO2 emissions (% of total fuel combustion) in 1963 in Australia to that in Belgium?
Your answer should be very brief. 3.36. What is the ratio of the CO2 emissions (% of total fuel combustion) in 1960 in Austria to that in Belgium?
Give a very brief answer. 2.25. What is the ratio of the CO2 emissions (% of total fuel combustion) in 1961 in Austria to that in Belgium?
Your response must be concise. 2.26. What is the ratio of the CO2 emissions (% of total fuel combustion) in 1962 in Austria to that in Belgium?
Give a very brief answer. 2.38. What is the ratio of the CO2 emissions (% of total fuel combustion) of 1963 in Austria to that in Belgium?
Keep it short and to the point. 2.54. What is the difference between the highest and the second highest CO2 emissions (% of total fuel combustion) of 1960?
Your answer should be very brief. 8.38. What is the difference between the highest and the second highest CO2 emissions (% of total fuel combustion) in 1961?
Your answer should be compact. 10.18. What is the difference between the highest and the second highest CO2 emissions (% of total fuel combustion) of 1962?
Provide a short and direct response. 8.91. What is the difference between the highest and the second highest CO2 emissions (% of total fuel combustion) of 1963?
Keep it short and to the point. 7.2. What is the difference between the highest and the lowest CO2 emissions (% of total fuel combustion) of 1960?
Your answer should be very brief. 24.71. What is the difference between the highest and the lowest CO2 emissions (% of total fuel combustion) of 1961?
Provide a succinct answer. 25.28. What is the difference between the highest and the lowest CO2 emissions (% of total fuel combustion) in 1962?
Your response must be concise. 24.83. What is the difference between the highest and the lowest CO2 emissions (% of total fuel combustion) in 1963?
Keep it short and to the point. 24.33. 